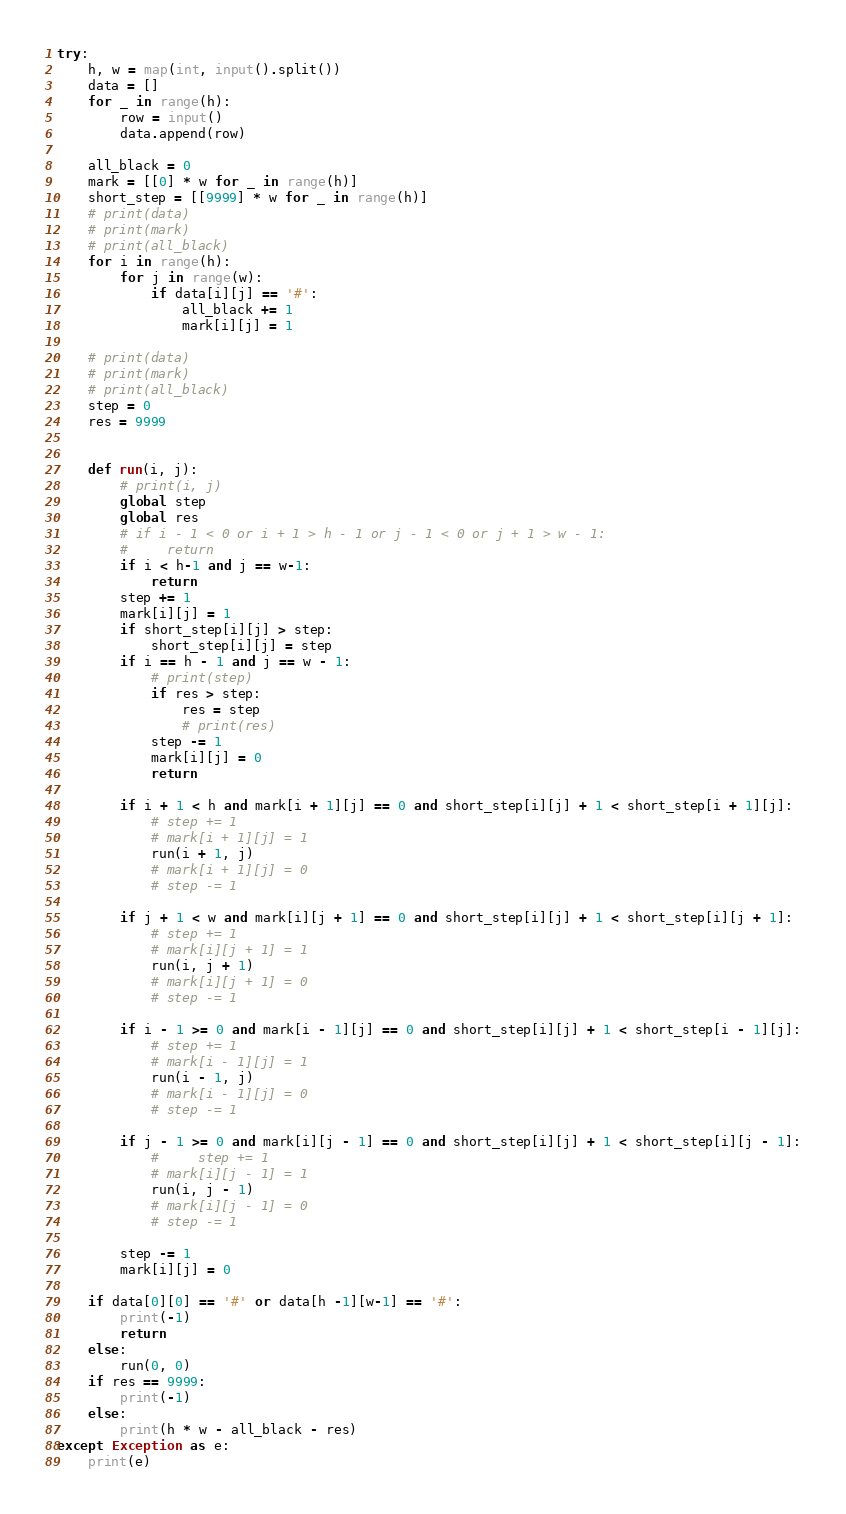<code> <loc_0><loc_0><loc_500><loc_500><_Python_>try:
    h, w = map(int, input().split())
    data = []
    for _ in range(h):
        row = input()
        data.append(row)

    all_black = 0
    mark = [[0] * w for _ in range(h)]
    short_step = [[9999] * w for _ in range(h)]
    # print(data)
    # print(mark)
    # print(all_black)
    for i in range(h):
        for j in range(w):
            if data[i][j] == '#':
                all_black += 1
                mark[i][j] = 1

    # print(data)
    # print(mark)
    # print(all_black)
    step = 0
    res = 9999


    def run(i, j):
        # print(i, j)
        global step
        global res
        # if i - 1 < 0 or i + 1 > h - 1 or j - 1 < 0 or j + 1 > w - 1:
        #     return
        if i < h-1 and j == w-1:
            return
        step += 1
        mark[i][j] = 1
        if short_step[i][j] > step:
            short_step[i][j] = step
        if i == h - 1 and j == w - 1:
            # print(step)
            if res > step:
                res = step
                # print(res)
            step -= 1
            mark[i][j] = 0
            return

        if i + 1 < h and mark[i + 1][j] == 0 and short_step[i][j] + 1 < short_step[i + 1][j]:
            # step += 1
            # mark[i + 1][j] = 1
            run(i + 1, j)
            # mark[i + 1][j] = 0
            # step -= 1

        if j + 1 < w and mark[i][j + 1] == 0 and short_step[i][j] + 1 < short_step[i][j + 1]:
            # step += 1
            # mark[i][j + 1] = 1
            run(i, j + 1)
            # mark[i][j + 1] = 0
            # step -= 1

        if i - 1 >= 0 and mark[i - 1][j] == 0 and short_step[i][j] + 1 < short_step[i - 1][j]:
            # step += 1
            # mark[i - 1][j] = 1
            run(i - 1, j)
            # mark[i - 1][j] = 0
            # step -= 1

        if j - 1 >= 0 and mark[i][j - 1] == 0 and short_step[i][j] + 1 < short_step[i][j - 1]:
            #     step += 1
            # mark[i][j - 1] = 1
            run(i, j - 1)
            # mark[i][j - 1] = 0
            # step -= 1

        step -= 1
        mark[i][j] = 0

    if data[0][0] == '#' or data[h -1][w-1] == '#':
        print(-1)
        return
    else:
        run(0, 0)
    if res == 9999:
        print(-1)
    else:
        print(h * w - all_black - res)
except Exception as e:
    print(e)</code> 